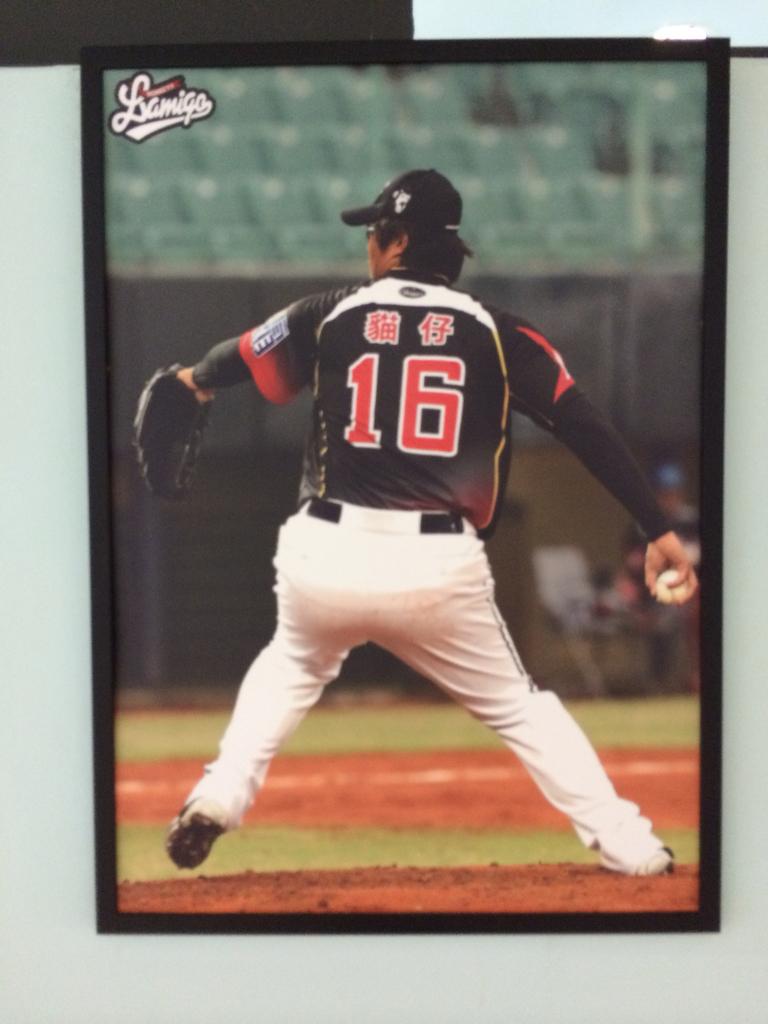What number is on this man's jersey?
Your response must be concise. 16. 